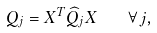<formula> <loc_0><loc_0><loc_500><loc_500>Q _ { j } = X ^ { T } \widehat { Q } _ { j } X \quad \forall \, j ,</formula> 